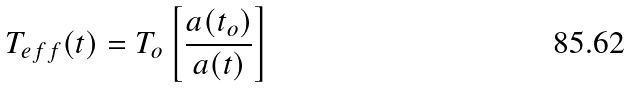Convert formula to latex. <formula><loc_0><loc_0><loc_500><loc_500>T _ { e f f } ( t ) = T _ { o } \left [ \frac { a ( t _ { o } ) } { a ( t ) } \right ]</formula> 